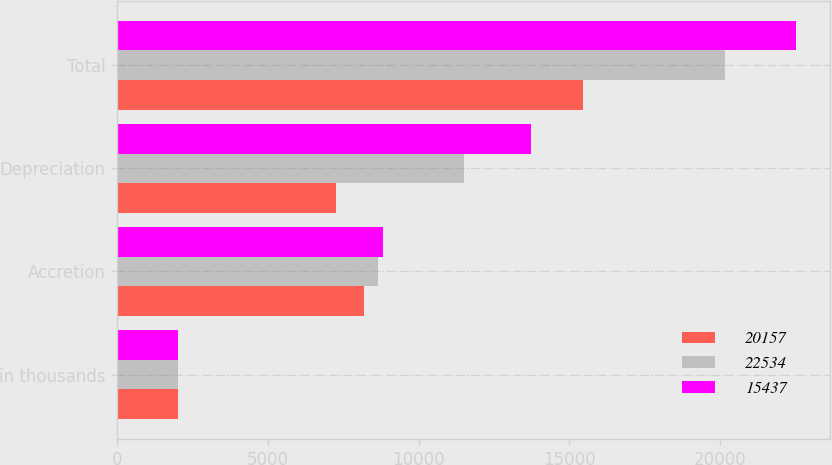<chart> <loc_0><loc_0><loc_500><loc_500><stacked_bar_chart><ecel><fcel>in thousands<fcel>Accretion<fcel>Depreciation<fcel>Total<nl><fcel>20157<fcel>2011<fcel>8195<fcel>7242<fcel>15437<nl><fcel>22534<fcel>2010<fcel>8641<fcel>11516<fcel>20157<nl><fcel>15437<fcel>2009<fcel>8802<fcel>13732<fcel>22534<nl></chart> 